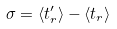Convert formula to latex. <formula><loc_0><loc_0><loc_500><loc_500>\sigma = \langle t _ { r } ^ { \prime } \rangle - \langle t _ { r } \rangle</formula> 